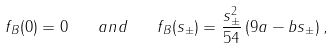Convert formula to latex. <formula><loc_0><loc_0><loc_500><loc_500>f _ { B } ( 0 ) = 0 \quad a n d \quad f _ { B } ( s _ { \pm } ) = \frac { s _ { \pm } ^ { 2 } } { 5 4 } \left ( 9 a - b s _ { \pm } \right ) ,</formula> 